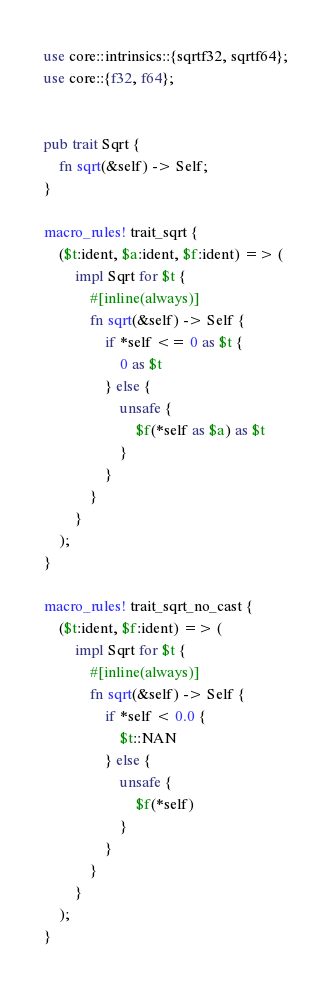<code> <loc_0><loc_0><loc_500><loc_500><_Rust_>use core::intrinsics::{sqrtf32, sqrtf64};
use core::{f32, f64};


pub trait Sqrt {
    fn sqrt(&self) -> Self;
}

macro_rules! trait_sqrt {
    ($t:ident, $a:ident, $f:ident) => (
        impl Sqrt for $t {
            #[inline(always)]
            fn sqrt(&self) -> Self {
                if *self <= 0 as $t {
                    0 as $t
                } else {
                    unsafe {
                        $f(*self as $a) as $t
                    }
                }
            }
        }
    );
}

macro_rules! trait_sqrt_no_cast {
    ($t:ident, $f:ident) => (
        impl Sqrt for $t {
            #[inline(always)]
            fn sqrt(&self) -> Self {
                if *self < 0.0 {
                    $t::NAN
                } else {
                    unsafe {
                        $f(*self)
                    }
                }
            }
        }
    );
}
</code> 